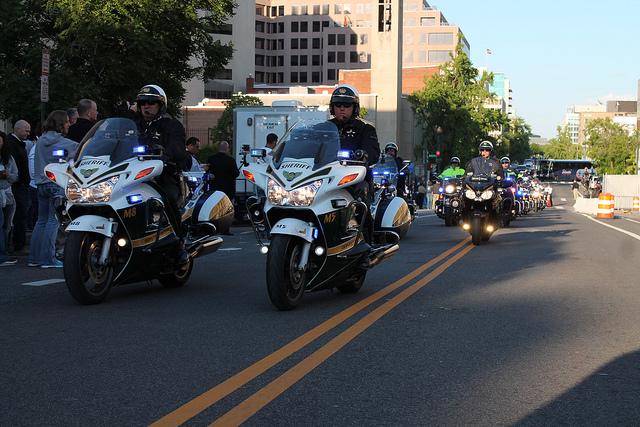Are the people on motorcycles cops?
Give a very brief answer. Yes. How many plastic face shields are on the motorcycles?
Answer briefly. 1. Why is part of the road dark?
Give a very brief answer. Shadow. How many yellow lines are on the road?
Give a very brief answer. 2. 